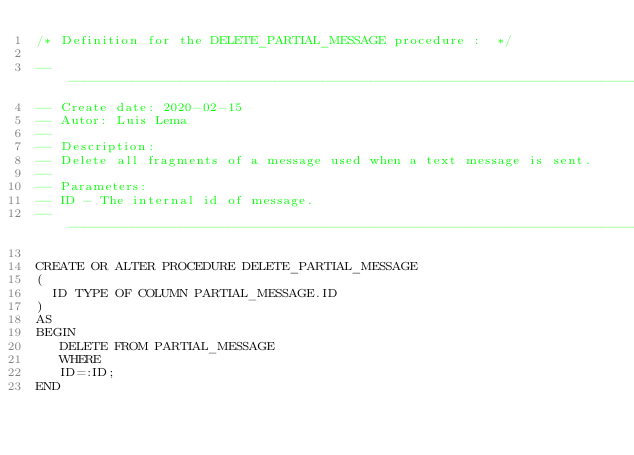Convert code to text. <code><loc_0><loc_0><loc_500><loc_500><_SQL_>/* Definition for the DELETE_PARTIAL_MESSAGE procedure :  */

------------------------------------------------------------------------------
-- Create date: 2020-02-15
-- Autor: Luis Lema
--
-- Description: 
-- Delete all fragments of a message used when a text message is sent.
--
-- Parameters:
-- ID - The internal id of message.
------------------------------------------------------------------------------

CREATE OR ALTER PROCEDURE DELETE_PARTIAL_MESSAGE
(
  ID TYPE OF COLUMN PARTIAL_MESSAGE.ID
)
AS
BEGIN
   DELETE FROM PARTIAL_MESSAGE
   WHERE
   ID=:ID;
END</code> 